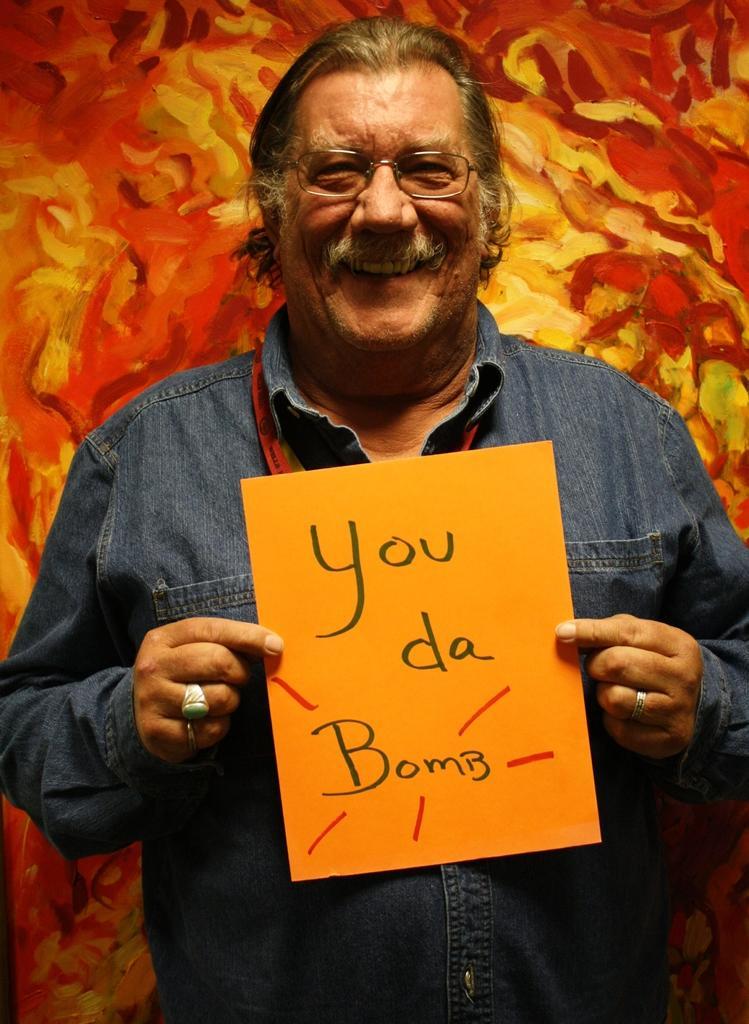Please provide a concise description of this image. In this image, we can see a man standing and holding a board in his hand. On the board, we can see some text written on it. In the background, we can also see orange color and yellow color. 